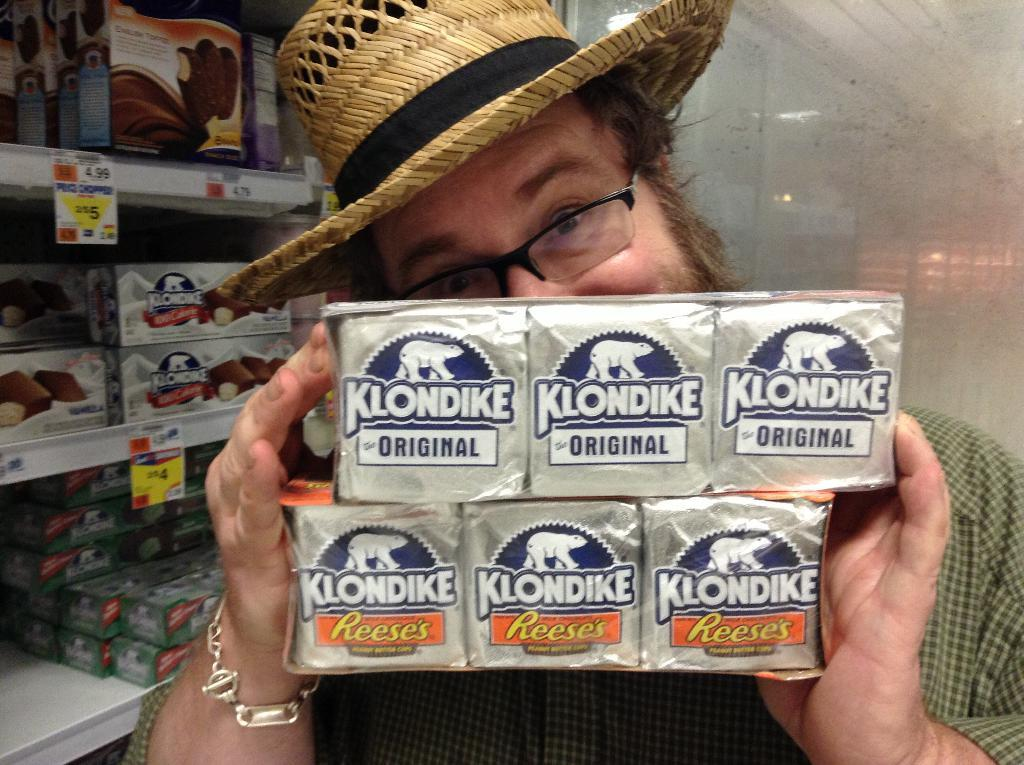Who is present in the image? There is a man in the image. What is the man wearing on his head? The man is wearing a hat. What is the man holding in the image? The man is holding someone's blocks. What type of furniture can be seen in the image? There is a cupboard in the image. What is on top of the cupboard? The cupboard has many things on it. What direction is the team moving in the image? There is no team present in the image, and therefore no direction of movement can be observed. Is there any toothpaste visible in the image? There is no toothpaste present in the image. 